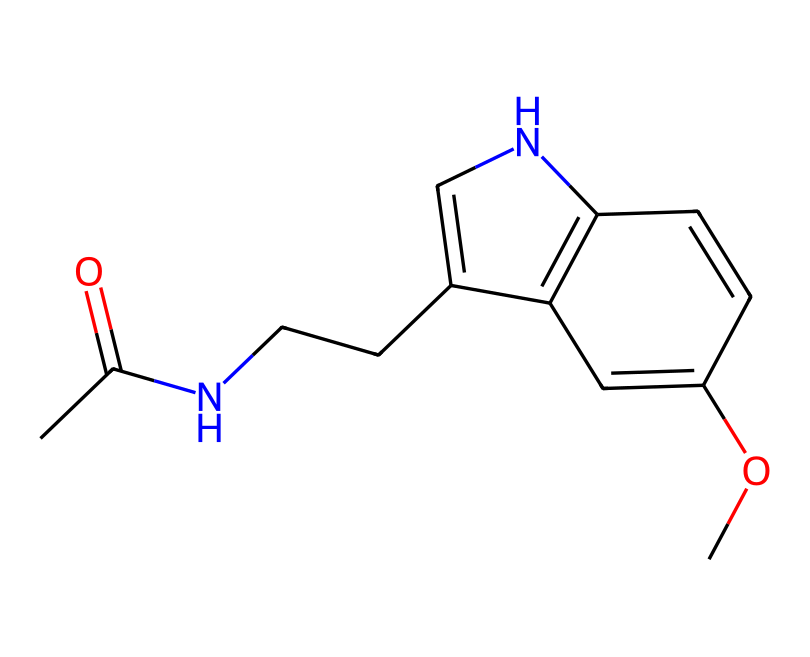What is the molecular formula of melatonin? To find the molecular formula, we analyze the structure by counting the individual atoms of each element present in the SMILES representation. The breakdown shows: 13 carbon (C), 16 hydrogen (H), 2 nitrogen (N), and 2 oxygen (O). Therefore, the molecular formula is C13H16N2O2.
Answer: C13H16N2O2 How many rings are present in this molecule? Inspecting the structure revealed in the SMILES indicates two distinct ring systems, which can be observed in the fused ring structure. Therefore, the total number of rings is 2.
Answer: 2 What type of bond connects carbon atoms in this molecule? The connectivity in this chemical structure primarily displays single and a few double bonds between carbon atoms, based on inspection of the SMILES. The most common bond type between carbon atoms is a single bond.
Answer: single bond What functional groups are present in melatonin? By analyzing the chemical structure, we can identify the presence of an acetamide group (due to the carbonyl and nitrogen) and methoxy group (due to the oxygen in the structure). These functional groups are indicative of melatonin's properties.
Answer: acetamide and methoxy What is the primary biological function of melatonin? Melatonin is primarily known for its role in regulating sleep cycles, often referred to as the sleep hormone, which influences circadian rhythms and sleep patterns.
Answer: sleep regulator What element is involved in the formation of the indole structure within melatonin? The indole structure of melatonin contains nitrogen as a key component, contributing to the aromatic ring system and its associated properties.
Answer: nitrogen How does the presence of nitrogen affect melatonin's behavior as a hormone? The presence of nitrogen atoms in melatonin affects its ability to interact with receptors in the body, facilitating its role in transmitting signals related to sleep and circadian rhythms. The nitrogen adds to the molecule's polarity and ability to engage in biochemical interactions.
Answer: increases receptor interaction 